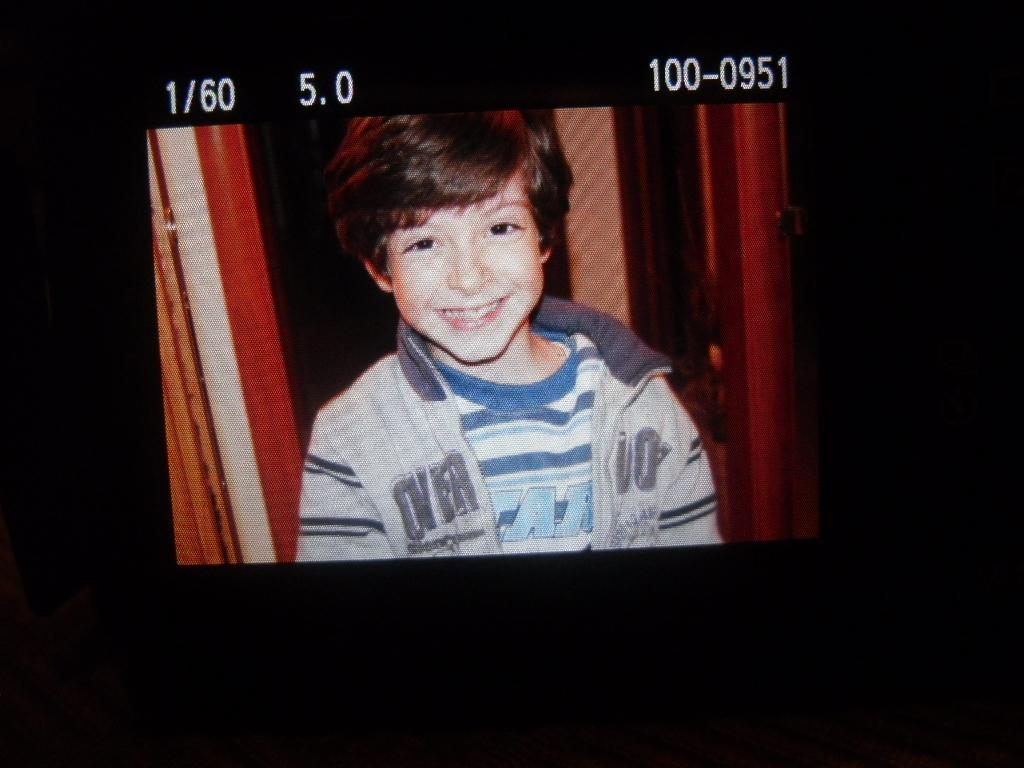Who is in the image? There is a boy in the image. What is the boy doing? The boy is laughing. What type of clothing is the boy wearing? The boy is wearing a t-shirt and a sweater. What else can be seen at the top of the image? There are numbers visible at the top of the image. What type of sand can be seen in the boy's eye in the image? There is no sand or eye visible in the image; it only shows a boy who is laughing while wearing a t-shirt and a sweater. 